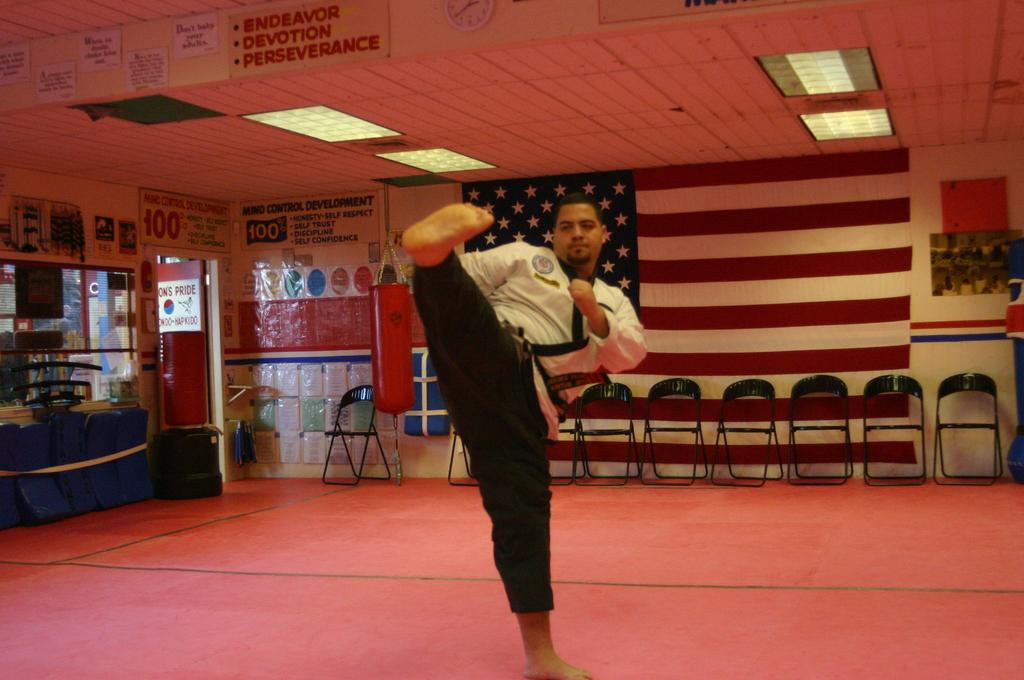<image>
Summarize the visual content of the image. A man demonstrates a karate kick under a banner that promotes perseverance. 